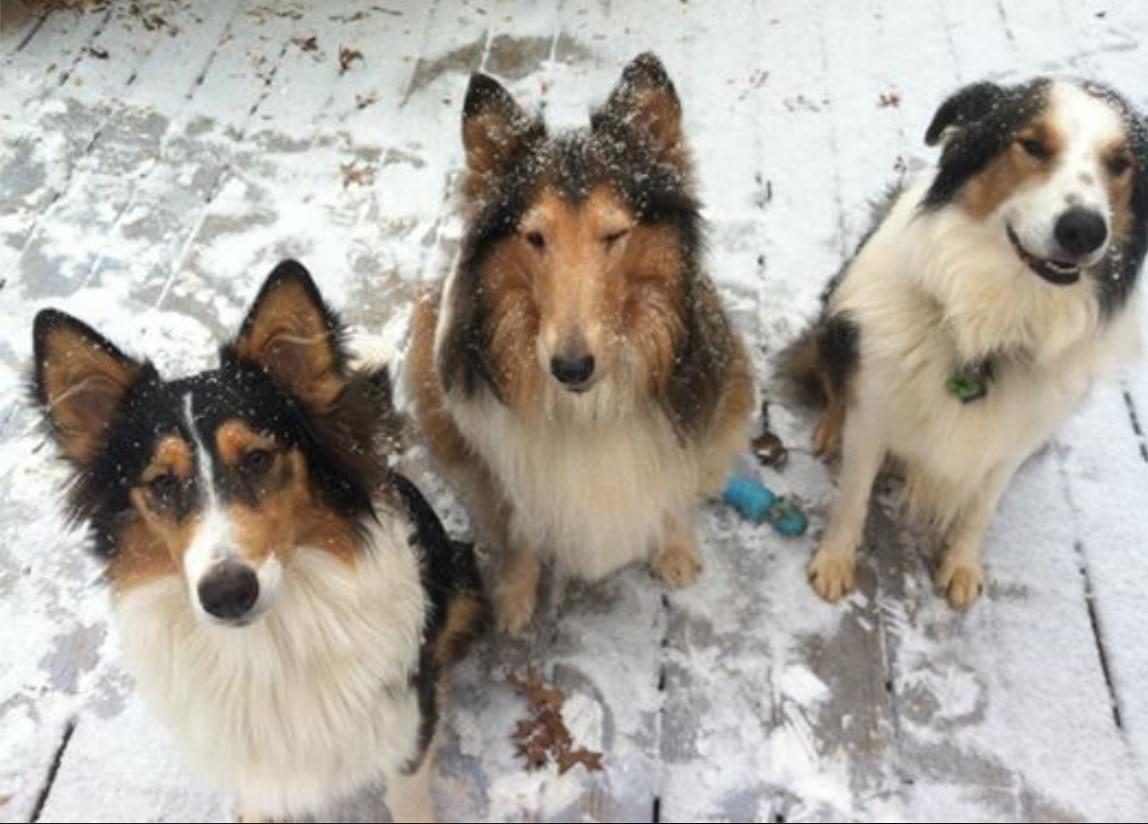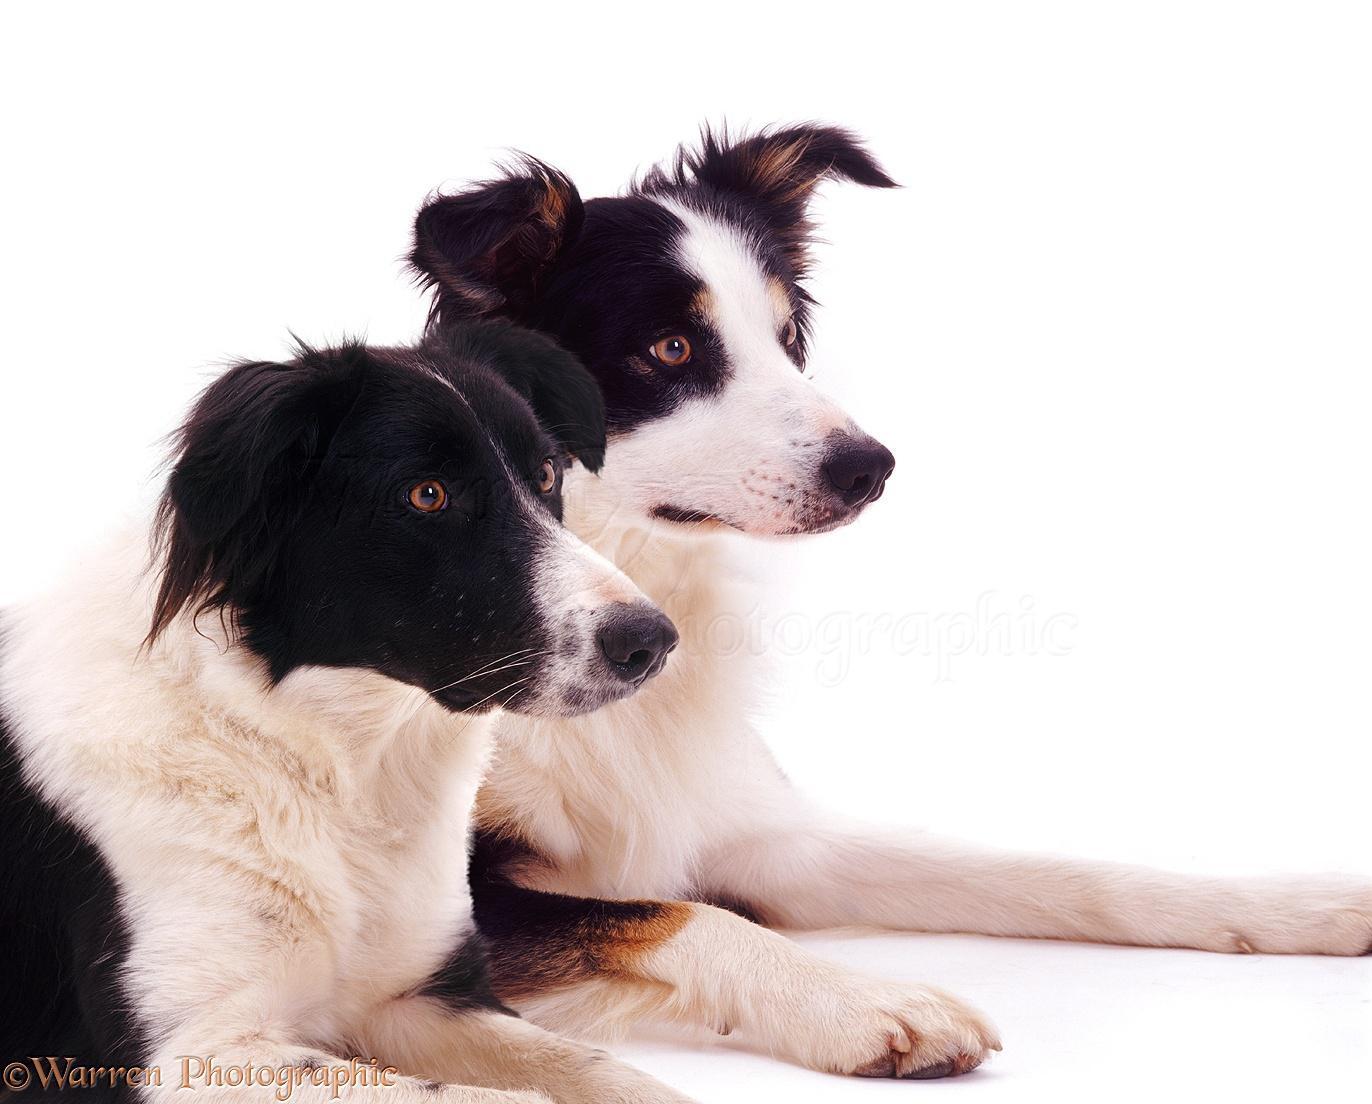The first image is the image on the left, the second image is the image on the right. For the images shown, is this caption "Exactly two dogs are lying together in one of the images." true? Answer yes or no. Yes. The first image is the image on the left, the second image is the image on the right. Analyze the images presented: Is the assertion "The right image contains exactly two dogs." valid? Answer yes or no. Yes. 